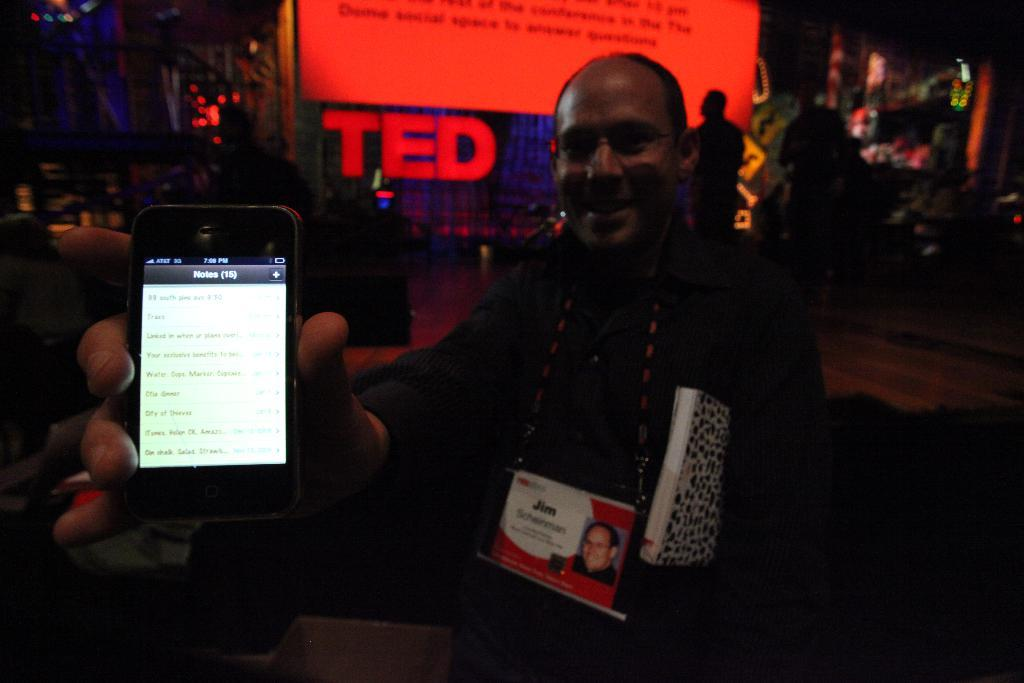Provide a one-sentence caption for the provided image. a man holding a phone at a TED talk. 